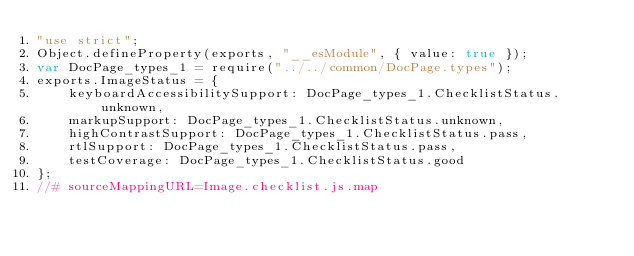<code> <loc_0><loc_0><loc_500><loc_500><_JavaScript_>"use strict";
Object.defineProperty(exports, "__esModule", { value: true });
var DocPage_types_1 = require("../../common/DocPage.types");
exports.ImageStatus = {
    keyboardAccessibilitySupport: DocPage_types_1.ChecklistStatus.unknown,
    markupSupport: DocPage_types_1.ChecklistStatus.unknown,
    highContrastSupport: DocPage_types_1.ChecklistStatus.pass,
    rtlSupport: DocPage_types_1.ChecklistStatus.pass,
    testCoverage: DocPage_types_1.ChecklistStatus.good
};
//# sourceMappingURL=Image.checklist.js.map</code> 